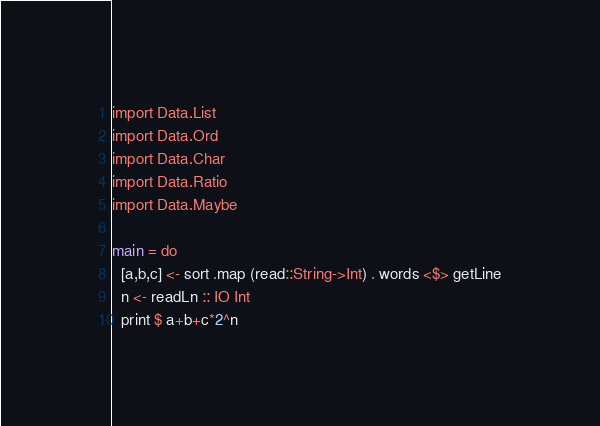Convert code to text. <code><loc_0><loc_0><loc_500><loc_500><_Haskell_>import Data.List
import Data.Ord
import Data.Char
import Data.Ratio
import Data.Maybe

main = do
  [a,b,c] <- sort .map (read::String->Int) . words <$> getLine
  n <- readLn :: IO Int
  print $ a+b+c*2^n</code> 